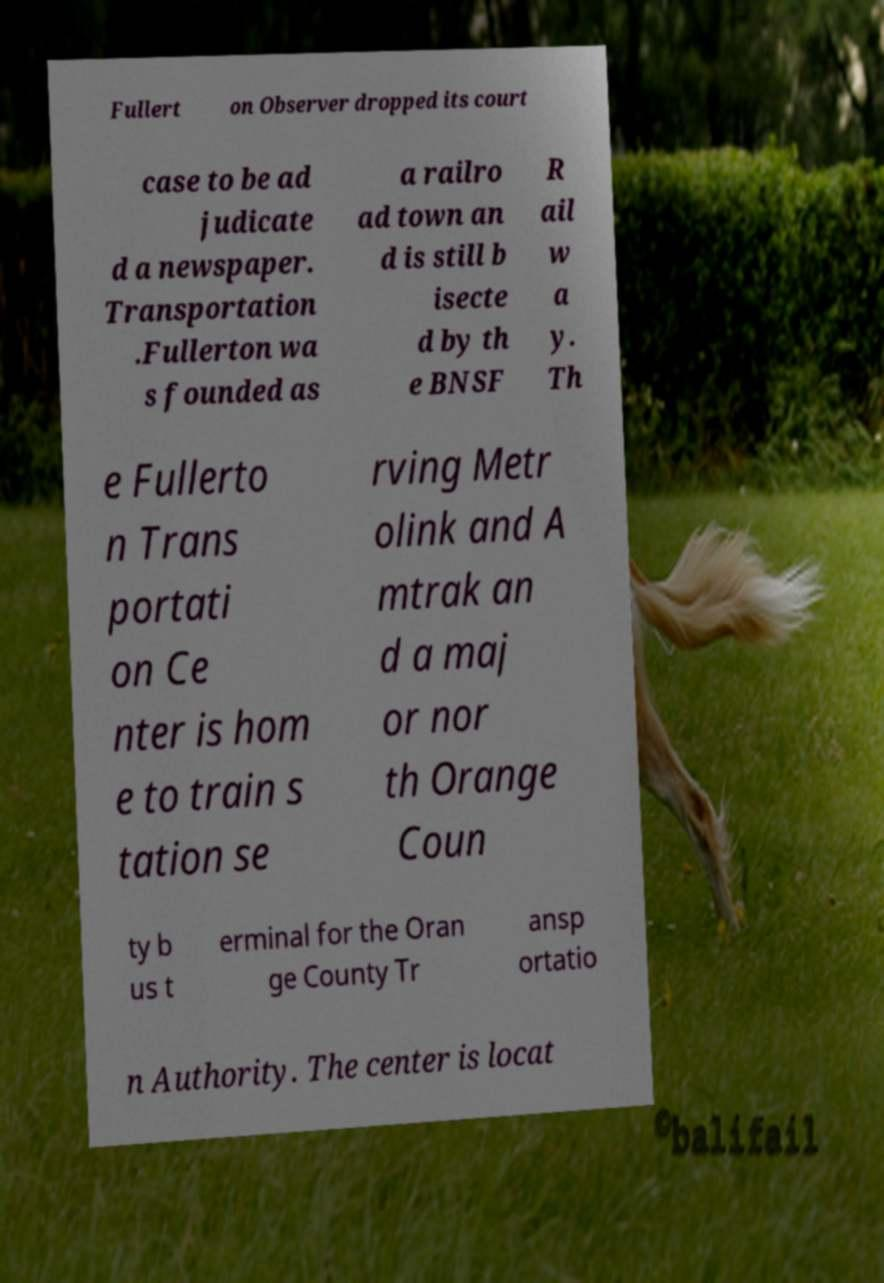There's text embedded in this image that I need extracted. Can you transcribe it verbatim? Fullert on Observer dropped its court case to be ad judicate d a newspaper. Transportation .Fullerton wa s founded as a railro ad town an d is still b isecte d by th e BNSF R ail w a y. Th e Fullerto n Trans portati on Ce nter is hom e to train s tation se rving Metr olink and A mtrak an d a maj or nor th Orange Coun ty b us t erminal for the Oran ge County Tr ansp ortatio n Authority. The center is locat 